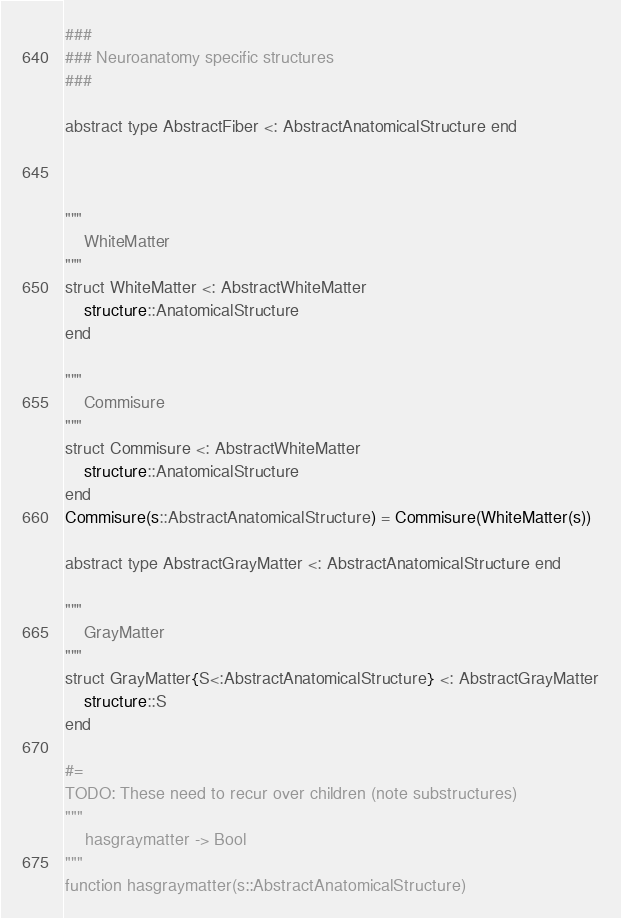<code> <loc_0><loc_0><loc_500><loc_500><_Julia_>
###
### Neuroanatomy specific structures
###

abstract type AbstractFiber <: AbstractAnatomicalStructure end



"""
    WhiteMatter
"""
struct WhiteMatter <: AbstractWhiteMatter
    structure::AnatomicalStructure
end

"""
    Commisure
"""
struct Commisure <: AbstractWhiteMatter
    structure::AnatomicalStructure
end
Commisure(s::AbstractAnatomicalStructure) = Commisure(WhiteMatter(s))

abstract type AbstractGrayMatter <: AbstractAnatomicalStructure end

"""
    GrayMatter
"""
struct GrayMatter{S<:AbstractAnatomicalStructure} <: AbstractGrayMatter
    structure::S
end

#=
TODO: These need to recur over children (note substructures)
"""
    hasgraymatter -> Bool
"""
function hasgraymatter(s::AbstractAnatomicalStructure)</code> 